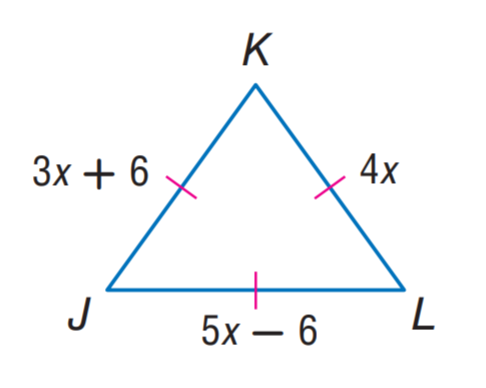Answer the mathemtical geometry problem and directly provide the correct option letter.
Question: Find J K.
Choices: A: 6 B: 18 C: 24 D: 42 C 